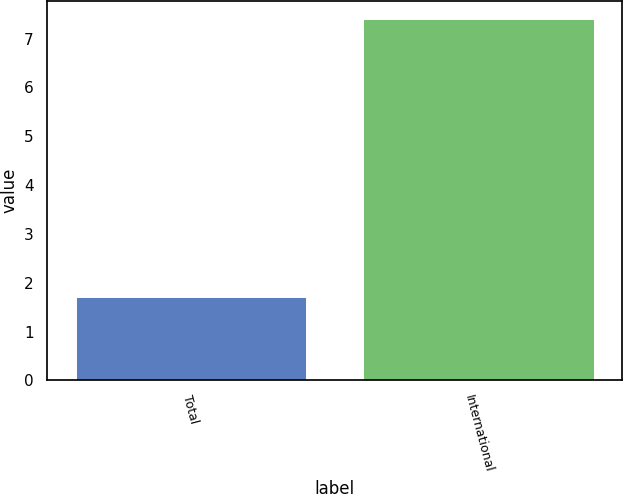Convert chart. <chart><loc_0><loc_0><loc_500><loc_500><bar_chart><fcel>Total<fcel>International<nl><fcel>1.7<fcel>7.4<nl></chart> 